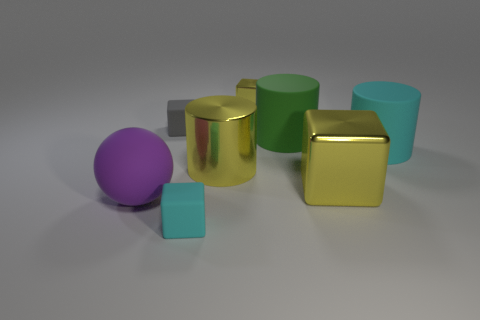Subtract all small yellow blocks. How many blocks are left? 3 Subtract all green cylinders. How many cylinders are left? 2 Add 1 green matte cylinders. How many objects exist? 9 Subtract 2 cylinders. How many cylinders are left? 1 Subtract all cyan cylinders. How many yellow blocks are left? 2 Subtract 0 gray balls. How many objects are left? 8 Subtract all cylinders. How many objects are left? 5 Subtract all gray balls. Subtract all green cylinders. How many balls are left? 1 Subtract all blocks. Subtract all red cylinders. How many objects are left? 4 Add 6 big purple balls. How many big purple balls are left? 7 